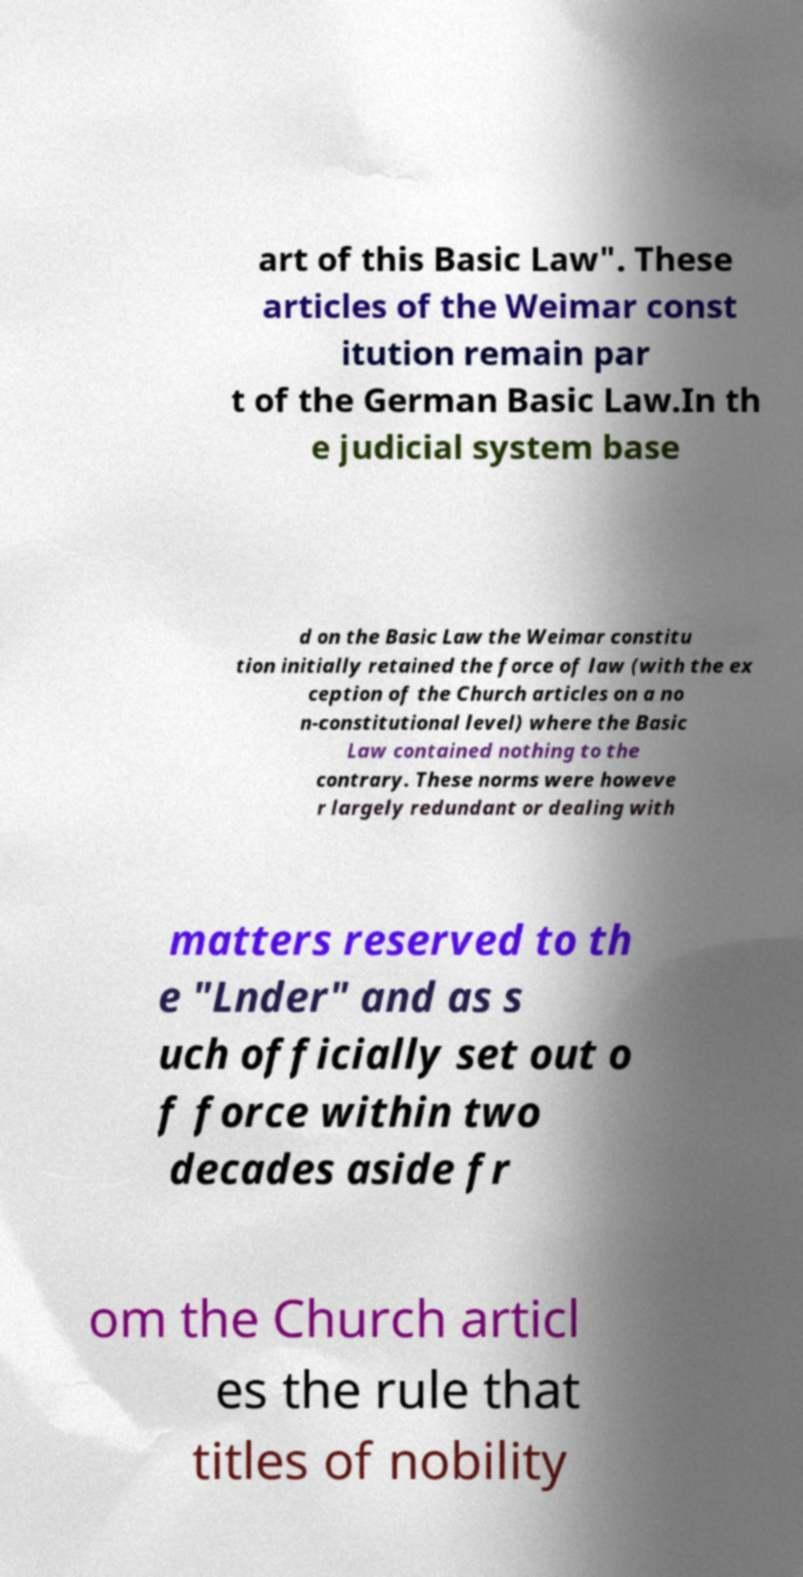There's text embedded in this image that I need extracted. Can you transcribe it verbatim? art of this Basic Law". These articles of the Weimar const itution remain par t of the German Basic Law.In th e judicial system base d on the Basic Law the Weimar constitu tion initially retained the force of law (with the ex ception of the Church articles on a no n-constitutional level) where the Basic Law contained nothing to the contrary. These norms were howeve r largely redundant or dealing with matters reserved to th e "Lnder" and as s uch officially set out o f force within two decades aside fr om the Church articl es the rule that titles of nobility 